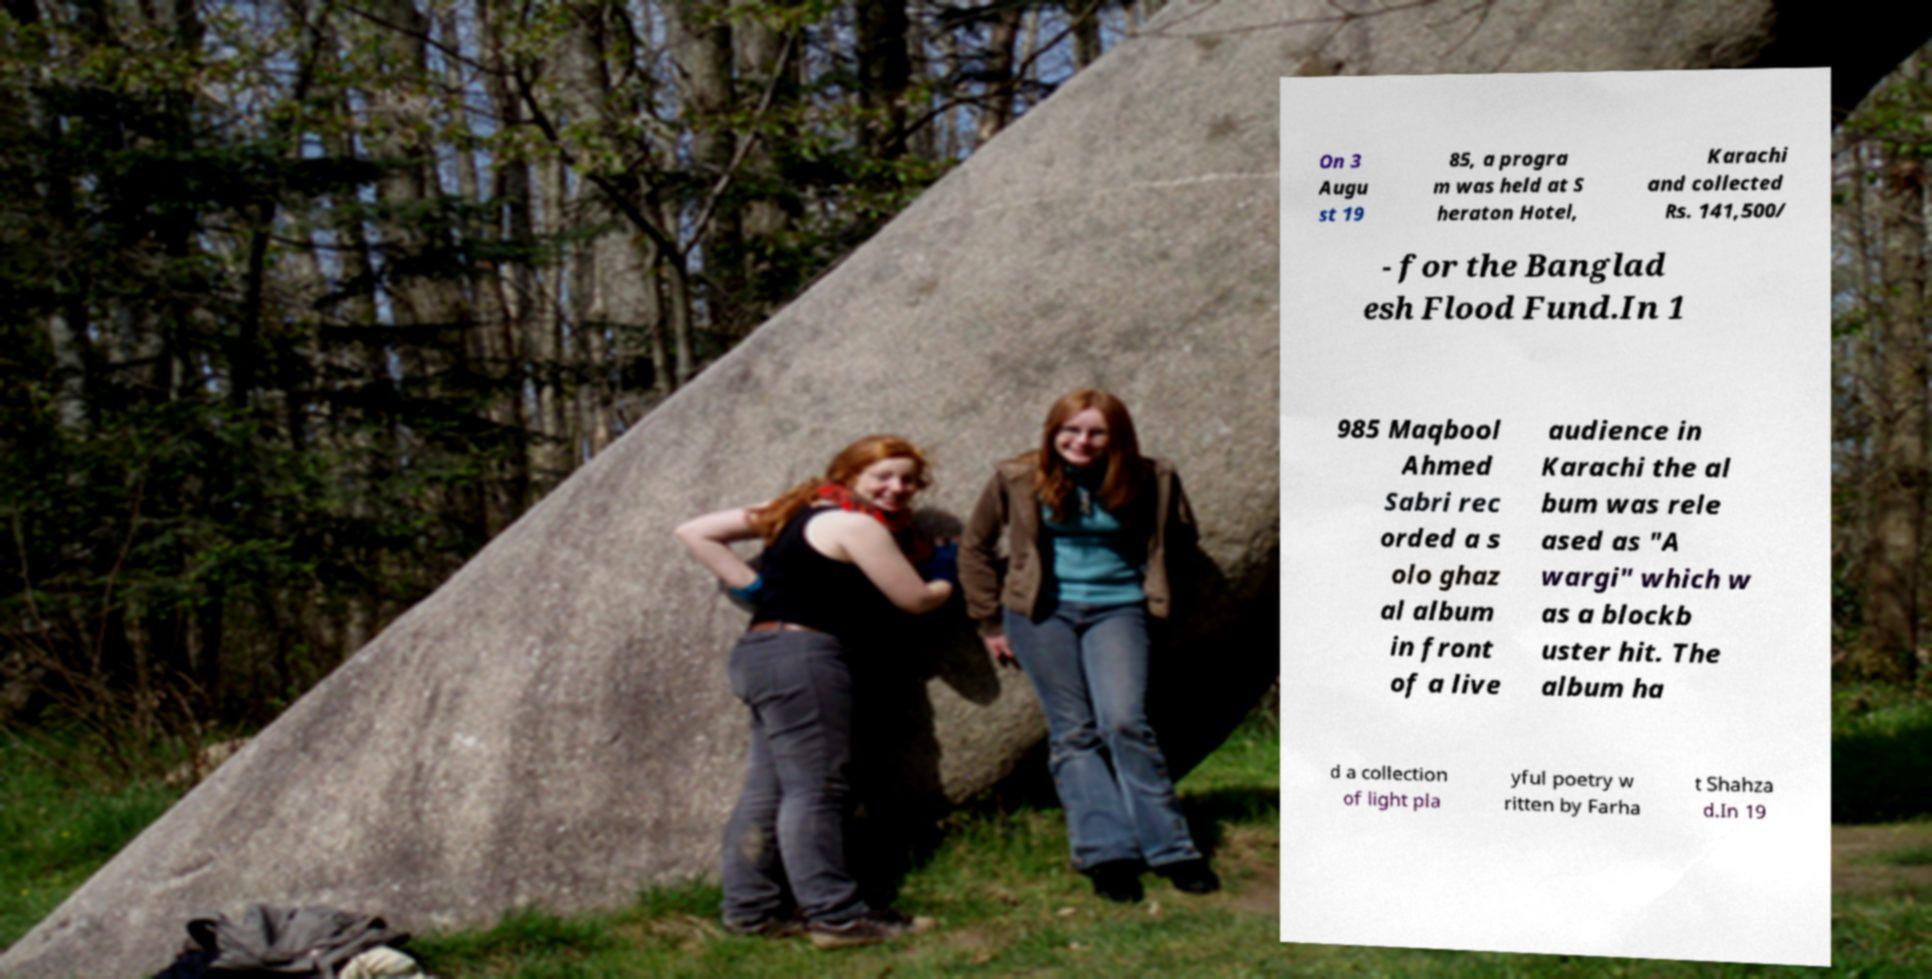Can you read and provide the text displayed in the image?This photo seems to have some interesting text. Can you extract and type it out for me? On 3 Augu st 19 85, a progra m was held at S heraton Hotel, Karachi and collected Rs. 141,500/ - for the Banglad esh Flood Fund.In 1 985 Maqbool Ahmed Sabri rec orded a s olo ghaz al album in front of a live audience in Karachi the al bum was rele ased as "A wargi" which w as a blockb uster hit. The album ha d a collection of light pla yful poetry w ritten by Farha t Shahza d.In 19 